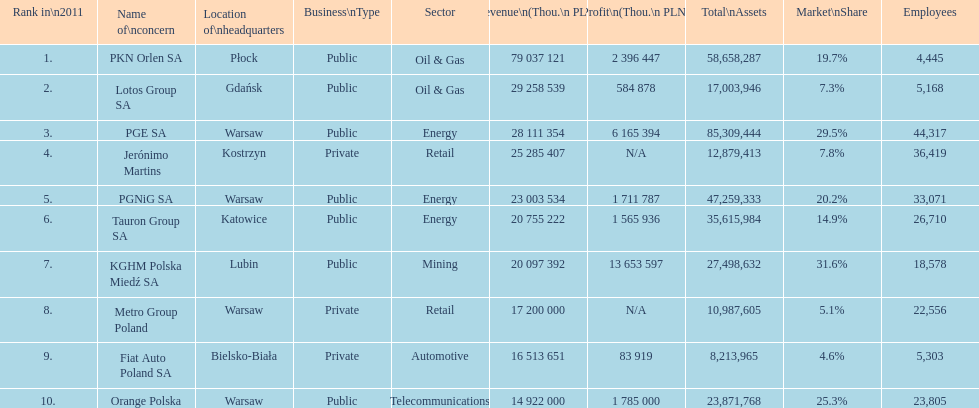Which organization has the unique distinction of having a revenue exceeding 75,000,000 thousand pln? PKN Orlen SA. 